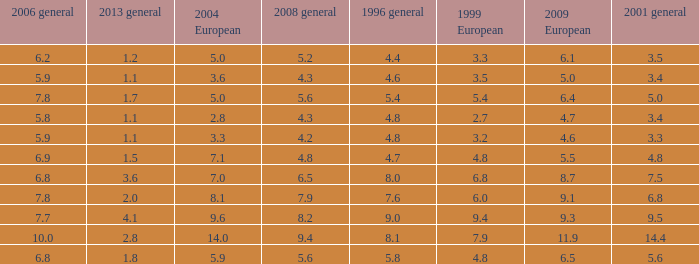What is the highest value for general 2008 when there is less than 5.5 in European 2009, more than 5.8 in general 2006, more than 3.3 in general 2001, and less than 3.6 for 2004 European? None. 